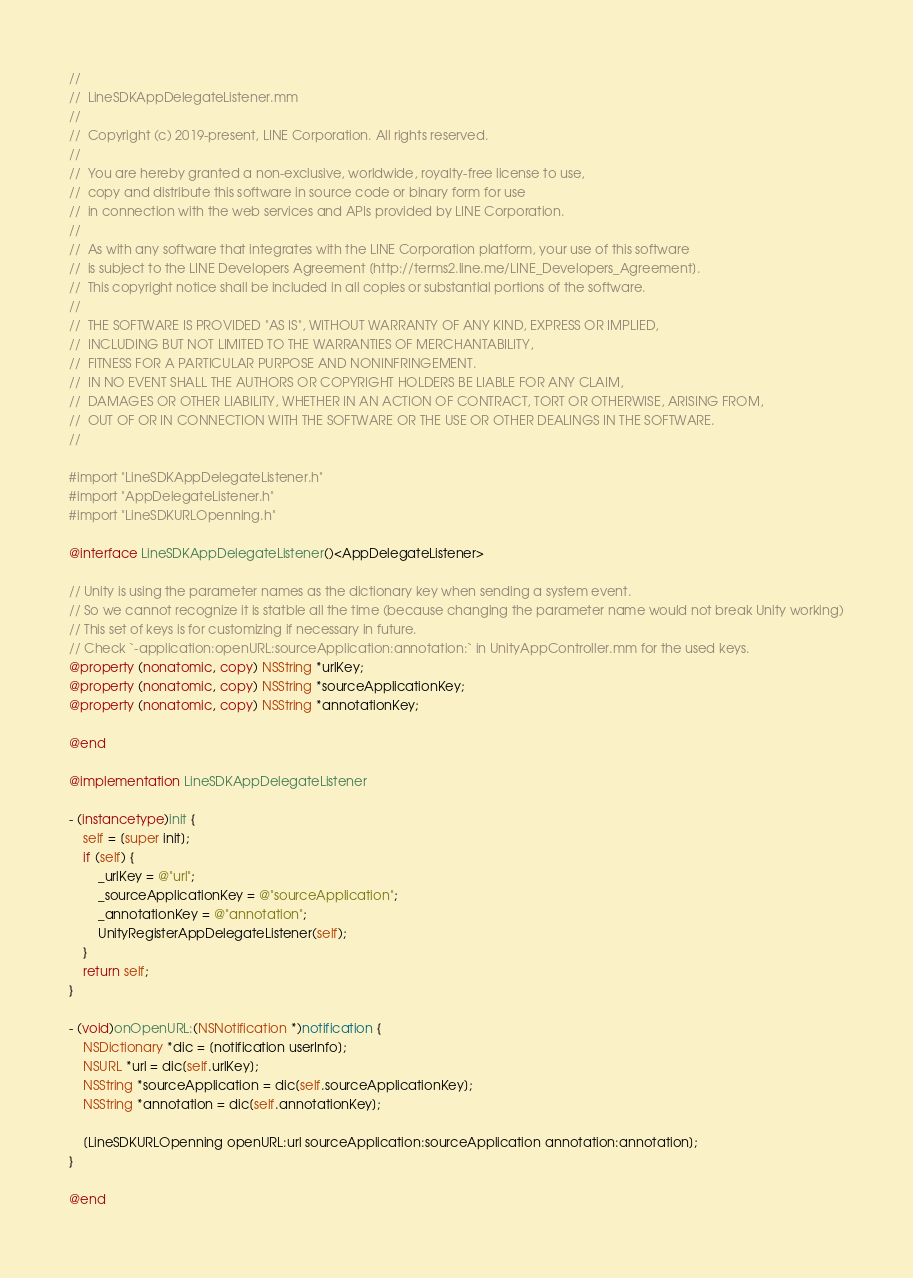<code> <loc_0><loc_0><loc_500><loc_500><_ObjectiveC_>//
//  LineSDKAppDelegateListener.mm
//
//  Copyright (c) 2019-present, LINE Corporation. All rights reserved.
//
//  You are hereby granted a non-exclusive, worldwide, royalty-free license to use,
//  copy and distribute this software in source code or binary form for use
//  in connection with the web services and APIs provided by LINE Corporation.
//
//  As with any software that integrates with the LINE Corporation platform, your use of this software
//  is subject to the LINE Developers Agreement [http://terms2.line.me/LINE_Developers_Agreement].
//  This copyright notice shall be included in all copies or substantial portions of the software.
//
//  THE SOFTWARE IS PROVIDED "AS IS", WITHOUT WARRANTY OF ANY KIND, EXPRESS OR IMPLIED,
//  INCLUDING BUT NOT LIMITED TO THE WARRANTIES OF MERCHANTABILITY,
//  FITNESS FOR A PARTICULAR PURPOSE AND NONINFRINGEMENT.
//  IN NO EVENT SHALL THE AUTHORS OR COPYRIGHT HOLDERS BE LIABLE FOR ANY CLAIM,
//  DAMAGES OR OTHER LIABILITY, WHETHER IN AN ACTION OF CONTRACT, TORT OR OTHERWISE, ARISING FROM,
//  OUT OF OR IN CONNECTION WITH THE SOFTWARE OR THE USE OR OTHER DEALINGS IN THE SOFTWARE.
//

#import "LineSDKAppDelegateListener.h"
#import "AppDelegateListener.h"
#import "LineSDKURLOpenning.h"

@interface LineSDKAppDelegateListener()<AppDelegateListener>

// Unity is using the parameter names as the dictionary key when sending a system event.
// So we cannot recognize it is statble all the time (because changing the parameter name would not break Unity working)
// This set of keys is for customizing if necessary in future.
// Check `-application:openURL:sourceApplication:annotation:` in UnityAppController.mm for the used keys.
@property (nonatomic, copy) NSString *urlKey;
@property (nonatomic, copy) NSString *sourceApplicationKey;
@property (nonatomic, copy) NSString *annotationKey;

@end

@implementation LineSDKAppDelegateListener

- (instancetype)init {
    self = [super init];
    if (self) {
        _urlKey = @"url";
        _sourceApplicationKey = @"sourceApplication";
        _annotationKey = @"annotation";
        UnityRegisterAppDelegateListener(self);
    }
    return self;
}

- (void)onOpenURL:(NSNotification *)notification {
    NSDictionary *dic = [notification userInfo];
    NSURL *url = dic[self.urlKey];
    NSString *sourceApplication = dic[self.sourceApplicationKey];
    NSString *annotation = dic[self.annotationKey];

    [LineSDKURLOpenning openURL:url sourceApplication:sourceApplication annotation:annotation];
}

@end
</code> 